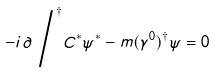<formula> <loc_0><loc_0><loc_500><loc_500>- i { \partial \, { \Big / } } ^ { \dagger } C ^ { * } \psi ^ { * } - m ( \gamma ^ { 0 } ) ^ { \dagger } \psi = 0</formula> 